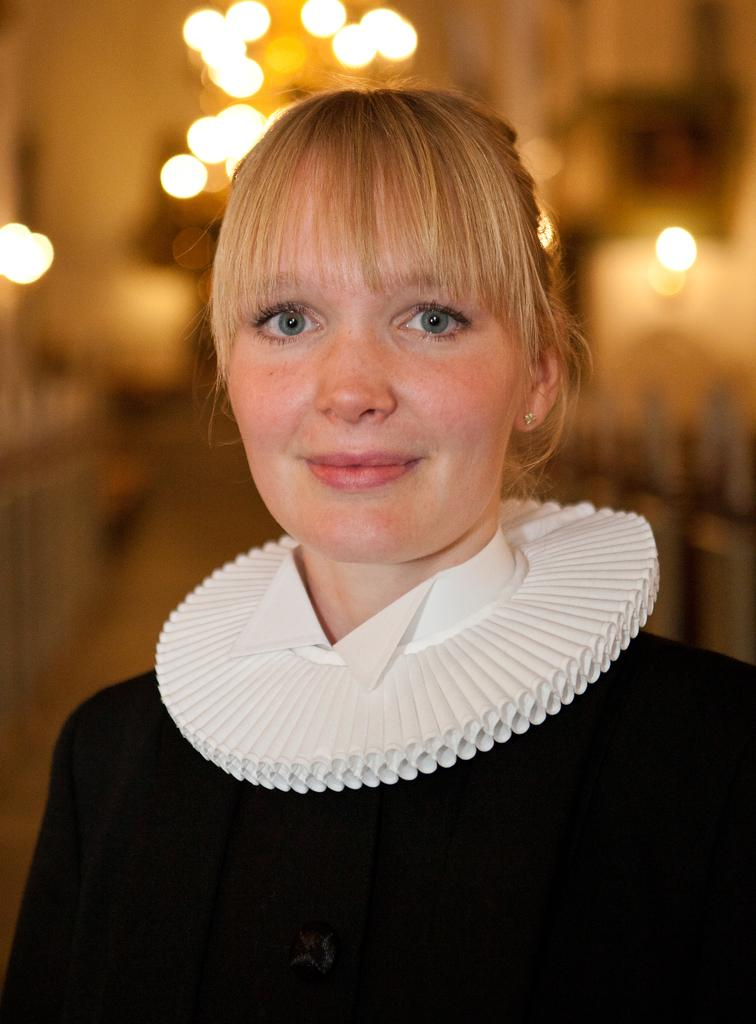What can be seen in the image? There is a person in the image. Can you describe the person's attire? The person is wearing a black and white dress. What else is visible in the image? There are lights visible in the image. How would you describe the background of the image? The background of the image is blurred. What type of juice is the person holding in the image? There is no juice present in the image; the person is not holding anything. 